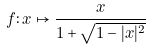Convert formula to latex. <formula><loc_0><loc_0><loc_500><loc_500>f \colon x \mapsto \frac { x } { 1 + \sqrt { 1 - | x | ^ { 2 } } }</formula> 